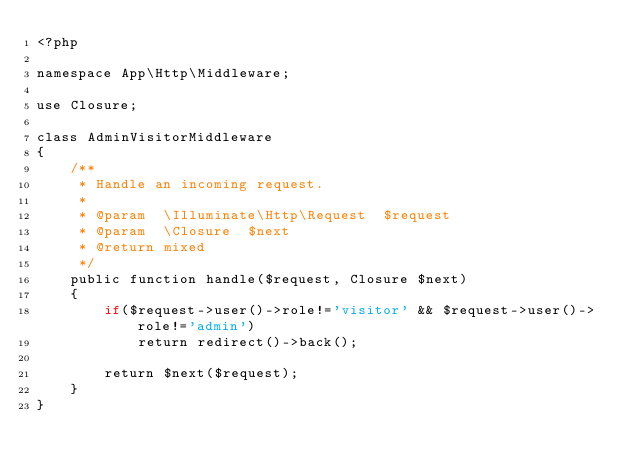<code> <loc_0><loc_0><loc_500><loc_500><_PHP_><?php

namespace App\Http\Middleware;

use Closure;

class AdminVisitorMiddleware
{
    /**
     * Handle an incoming request.
     *
     * @param  \Illuminate\Http\Request  $request
     * @param  \Closure  $next
     * @return mixed
     */
    public function handle($request, Closure $next)
    {
        if($request->user()->role!='visitor' && $request->user()->role!='admin')
            return redirect()->back();

        return $next($request);
    }
}
</code> 